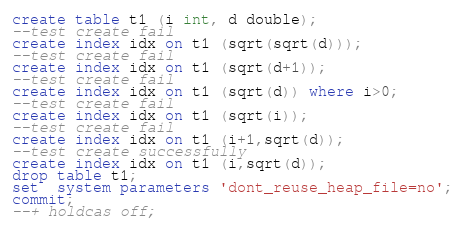Convert code to text. <code><loc_0><loc_0><loc_500><loc_500><_SQL_>create table t1 (i int, d double);
--test create fail
create index idx on t1 (sqrt(sqrt(d)));
--test create fail
create index idx on t1 (sqrt(d+1));
--test create fail
create index idx on t1 (sqrt(d)) where i>0;
--test create fail
create index idx on t1 (sqrt(i));
--test create fail
create index idx on t1 (i+1,sqrt(d));
--test create successfully
create index idx on t1 (i,sqrt(d));
drop table t1;
set  system parameters 'dont_reuse_heap_file=no';
commit;
--+ holdcas off;
</code> 